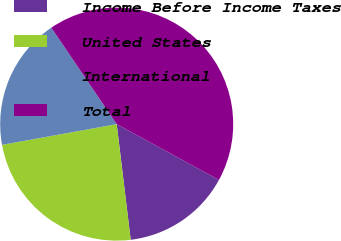Convert chart. <chart><loc_0><loc_0><loc_500><loc_500><pie_chart><fcel>Income Before Income Taxes<fcel>United States<fcel>International<fcel>Total<nl><fcel>15.13%<fcel>24.07%<fcel>18.36%<fcel>42.43%<nl></chart> 